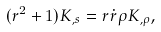<formula> <loc_0><loc_0><loc_500><loc_500>( r ^ { 2 } + 1 ) K _ { , s } = r \dot { r } \rho K _ { , \rho } ,</formula> 